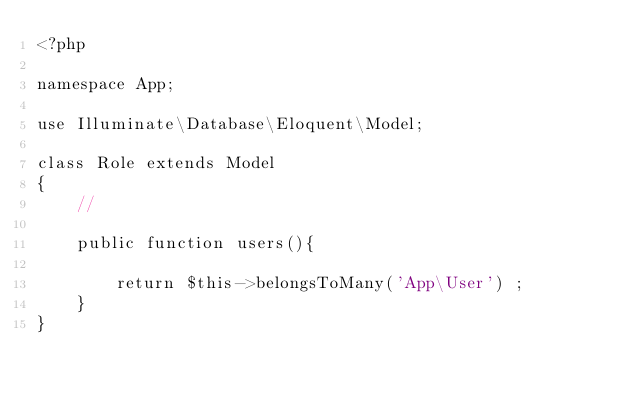Convert code to text. <code><loc_0><loc_0><loc_500><loc_500><_PHP_><?php

namespace App;

use Illuminate\Database\Eloquent\Model;

class Role extends Model
{
    //

    public function users(){

        return $this->belongsToMany('App\User') ;
    }
}
</code> 